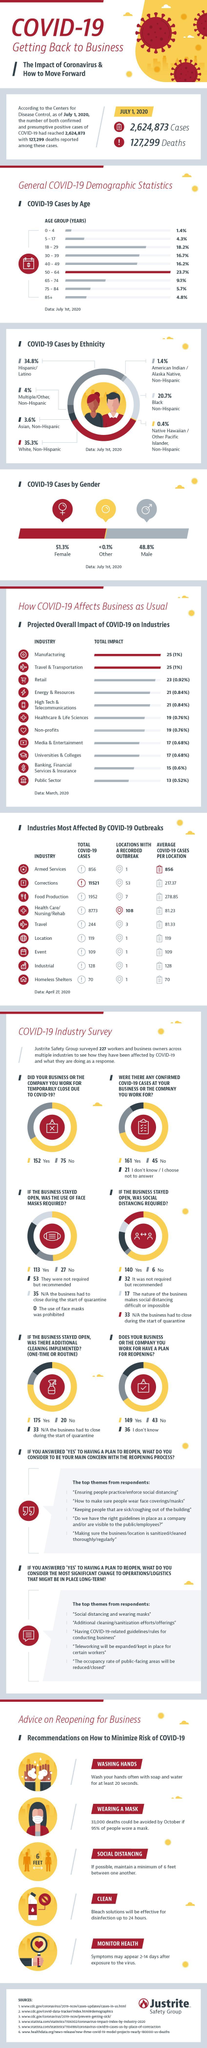Which ethnic group in America is most affected by the Covid-19 virus as of July 1, 2020?
Answer the question with a short phrase. White, Non-Hispanic What is the percent of COVID-19 cases in the Americans aged 40-49 years as of July 1, 2020? 16.2% How many respondents agree that their business or company will temporarily close due to COVID-19 as per the industry survey? 152 Which age group in America has recorded the highest percent of COVID-19 cases as of July 1, 2020? 50 - 64 How many respondents agree that their business or company had confirmed cases of COVID-19 as per the industry survey? 161 What percent of black non-hispanic people in the US are affected by COVID-19 as of July 1, 2020? 20.7% What percent of asian, non-hispanic people in the US are affected by COVID-19? 3.6% What percentage of male in the U.S. are affected by the Covid-19 virus as of July 1, 2020? 48.8% How many respondents agree that their business or company have a plan for reopening during COVID-19? 149 What is the total number of COVID-19 cases reported in the armed services of the US as of April 27, 2020? 856 